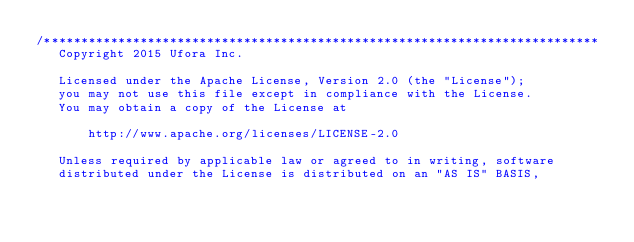Convert code to text. <code><loc_0><loc_0><loc_500><loc_500><_C++_>/***************************************************************************
   Copyright 2015 Ufora Inc.

   Licensed under the Apache License, Version 2.0 (the "License");
   you may not use this file except in compliance with the License.
   You may obtain a copy of the License at

       http://www.apache.org/licenses/LICENSE-2.0

   Unless required by applicable law or agreed to in writing, software
   distributed under the License is distributed on an "AS IS" BASIS,</code> 